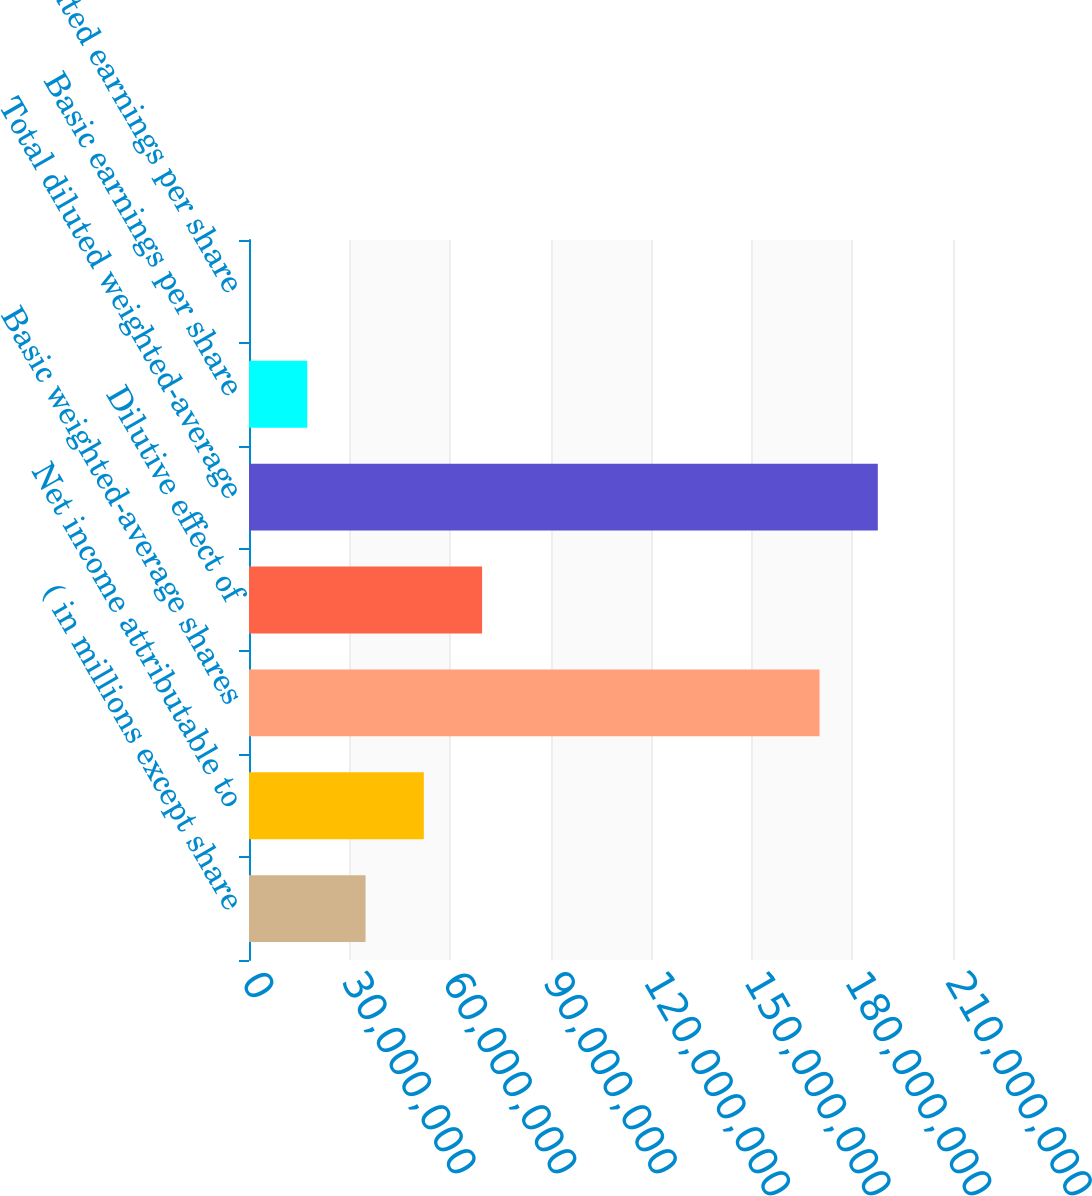<chart> <loc_0><loc_0><loc_500><loc_500><bar_chart><fcel>( in millions except share<fcel>Net income attributable to<fcel>Basic weighted-average shares<fcel>Dilutive effect of<fcel>Total diluted weighted-average<fcel>Basic earnings per share<fcel>Diluted earnings per share<nl><fcel>3.47658e+07<fcel>5.21487e+07<fcel>1.70186e+08<fcel>6.95316e+07<fcel>1.87569e+08<fcel>1.73829e+07<fcel>16.87<nl></chart> 